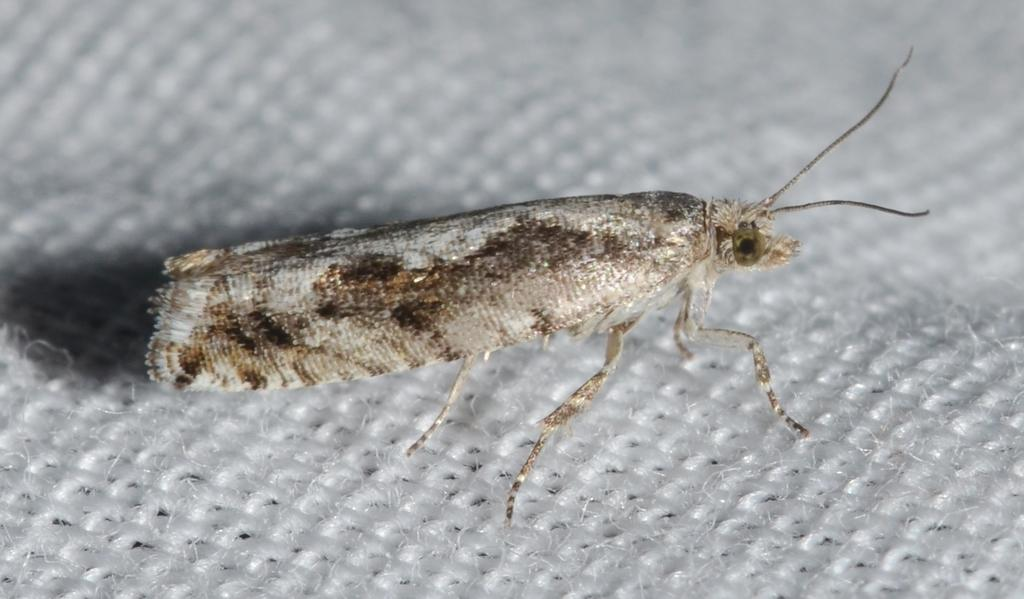What is the main subject in the center of the image? There is an insect in the center of the image. What is located at the bottom of the image? There is a cloth at the bottom of the image. What type of marble is visible in the image? There is no marble present in the image. Is the insect in the image capable of motion? The insect's ability to move cannot be determined from the image alone, as it is a still image. 